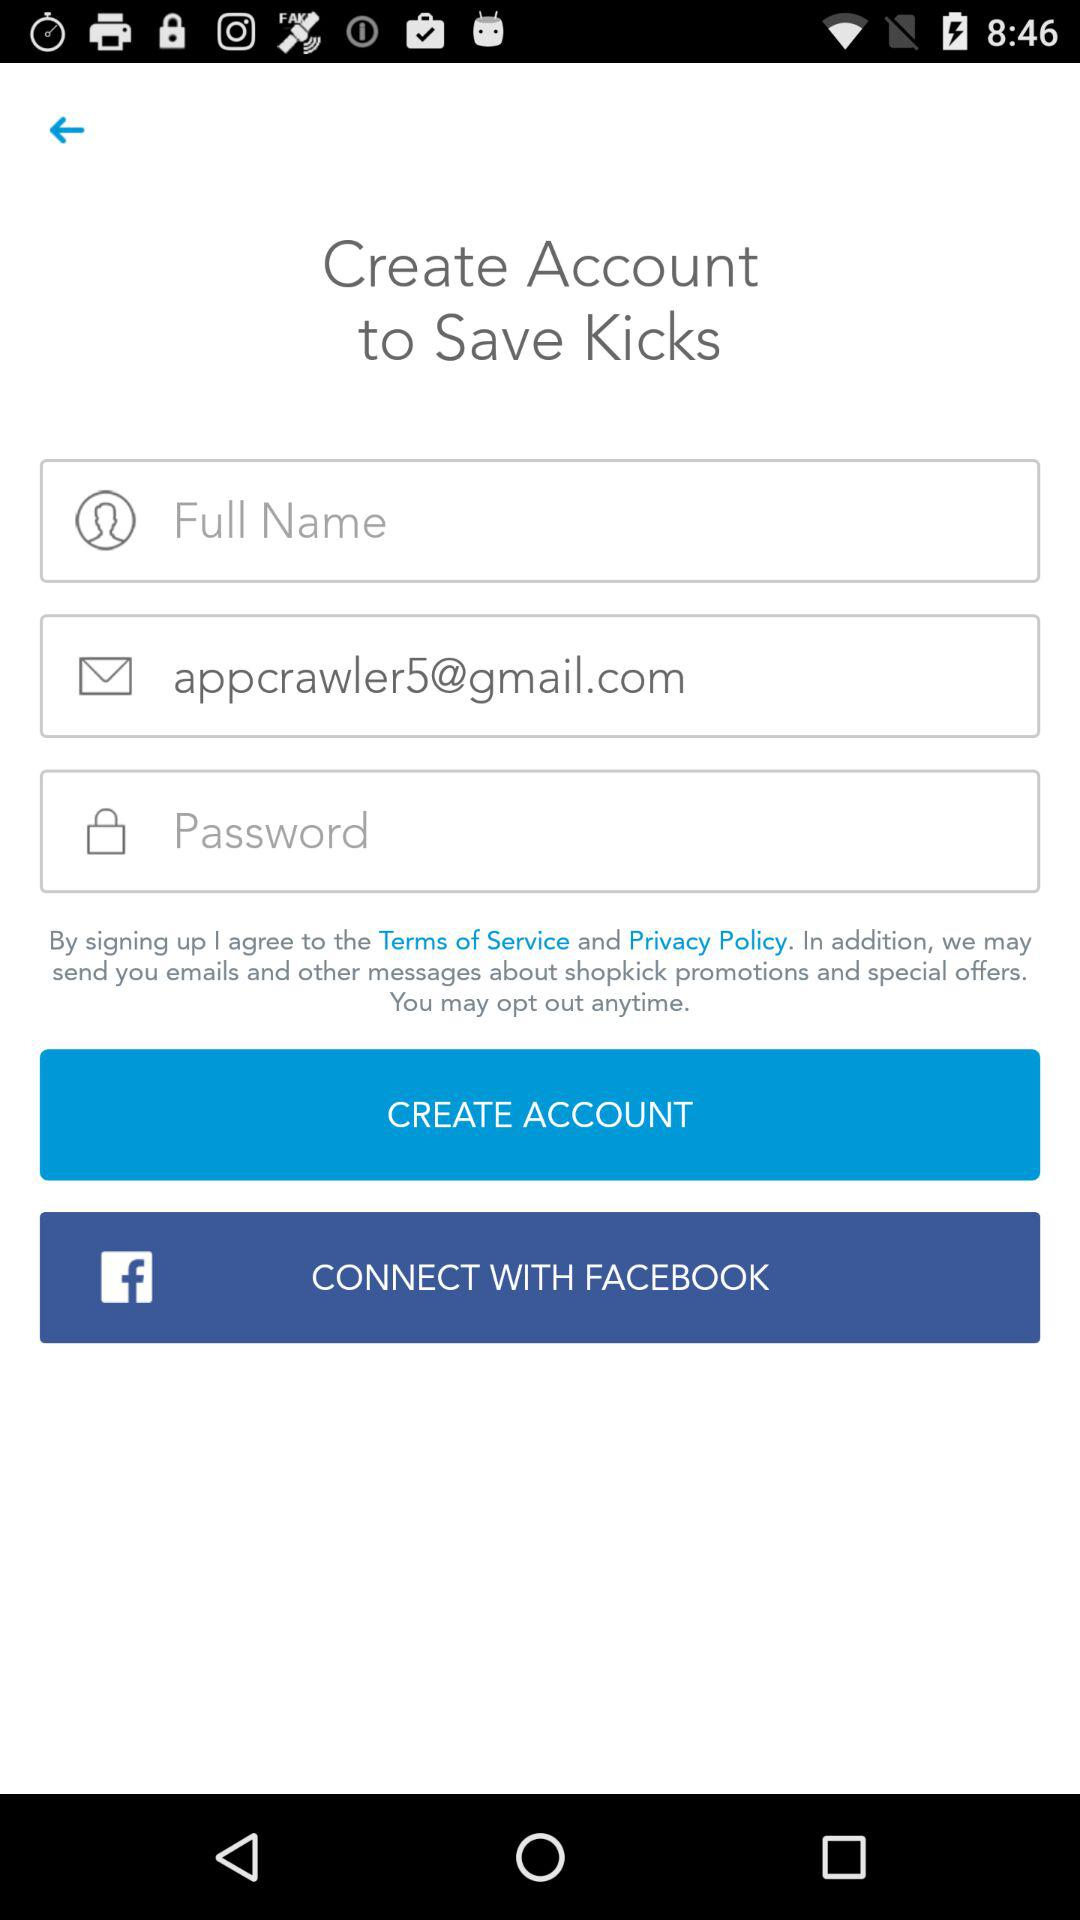What is the email address? The email address is appcrawler5@gmail.com. 